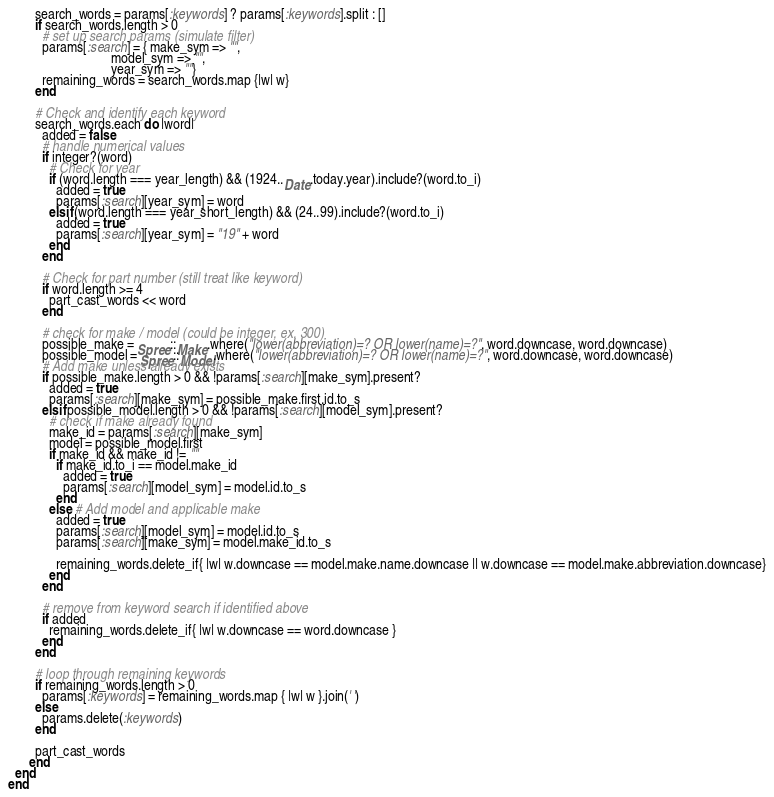<code> <loc_0><loc_0><loc_500><loc_500><_Ruby_>        search_words = params[:keywords] ? params[:keywords].split : []
        if search_words.length > 0
          # set up search params (simulate filter)
          params[:search] = { make_sym => "",
                              model_sym => "",
                              year_sym => ""}
          remaining_words = search_words.map {|w| w}
        end

        # Check and identify each keyword
        search_words.each do |word|
          added = false
          # handle numerical values
          if integer?(word)
            # Check for year
            if (word.length === year_length) && (1924..Date.today.year).include?(word.to_i)
              added = true
              params[:search][year_sym] = word
            elsif (word.length === year_short_length) && (24..99).include?(word.to_i)
              added = true
              params[:search][year_sym] = "19" + word
            end
          end

          # Check for part number (still treat like keyword)
          if word.length >= 4
            part_cast_words << word
          end

          # check for make / model (could be integer, ex. 300)
          possible_make = Spree::Make.where("lower(abbreviation)=? OR lower(name)=?", word.downcase, word.downcase)
          possible_model = Spree::Model.where("lower(abbreviation)=? OR lower(name)=?", word.downcase, word.downcase)
          # Add make unless already exists
          if possible_make.length > 0 && !params[:search][make_sym].present?
            added = true
            params[:search][make_sym] = possible_make.first.id.to_s
          elsif possible_model.length > 0 && !params[:search][model_sym].present?
            # check if make already found
            make_id = params[:search][make_sym]
            model = possible_model.first
            if make_id && make_id != ""
              if make_id.to_i == model.make_id
                added = true
                params[:search][model_sym] = model.id.to_s
              end
            else # Add model and applicable make
              added = true
              params[:search][model_sym] = model.id.to_s
              params[:search][make_sym] = model.make_id.to_s

              remaining_words.delete_if{ |w| w.downcase == model.make.name.downcase || w.downcase == model.make.abbreviation.downcase}
            end
          end

          # remove from keyword search if identified above
          if added
            remaining_words.delete_if{ |w| w.downcase == word.downcase }
          end
        end

        # loop through remaining keywords
        if remaining_words.length > 0
          params[:keywords] = remaining_words.map { |w| w }.join(' ')
        else
          params.delete(:keywords)
        end

        part_cast_words
      end
  end
end
</code> 